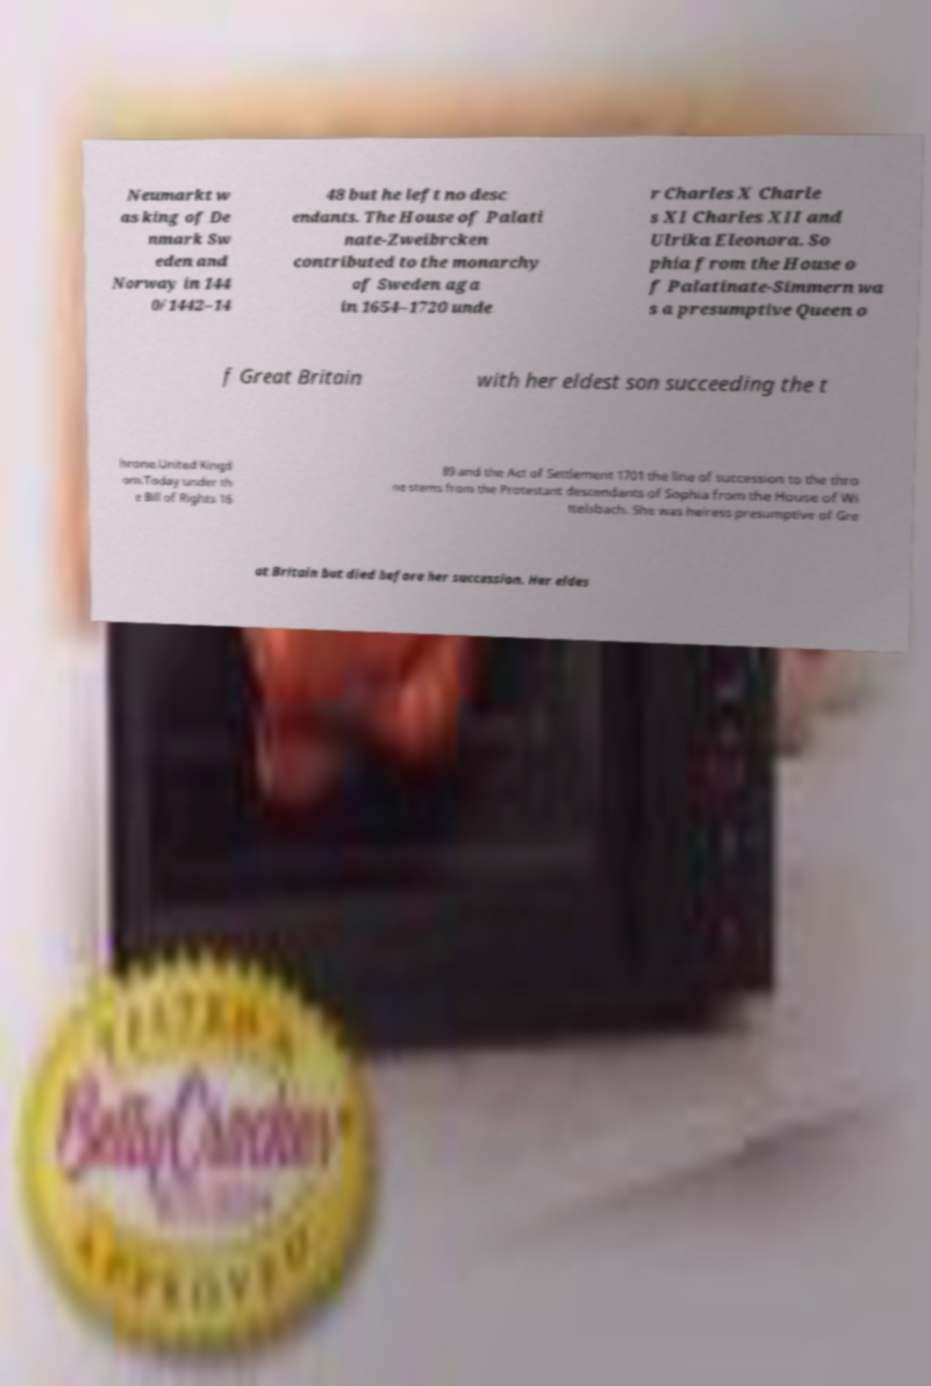For documentation purposes, I need the text within this image transcribed. Could you provide that? Neumarkt w as king of De nmark Sw eden and Norway in 144 0/1442–14 48 but he left no desc endants. The House of Palati nate-Zweibrcken contributed to the monarchy of Sweden aga in 1654–1720 unde r Charles X Charle s XI Charles XII and Ulrika Eleonora. So phia from the House o f Palatinate-Simmern wa s a presumptive Queen o f Great Britain with her eldest son succeeding the t hrone.United Kingd om.Today under th e Bill of Rights 16 89 and the Act of Settlement 1701 the line of succession to the thro ne stems from the Protestant descendants of Sophia from the House of Wi ttelsbach. She was heiress presumptive of Gre at Britain but died before her succession. Her eldes 